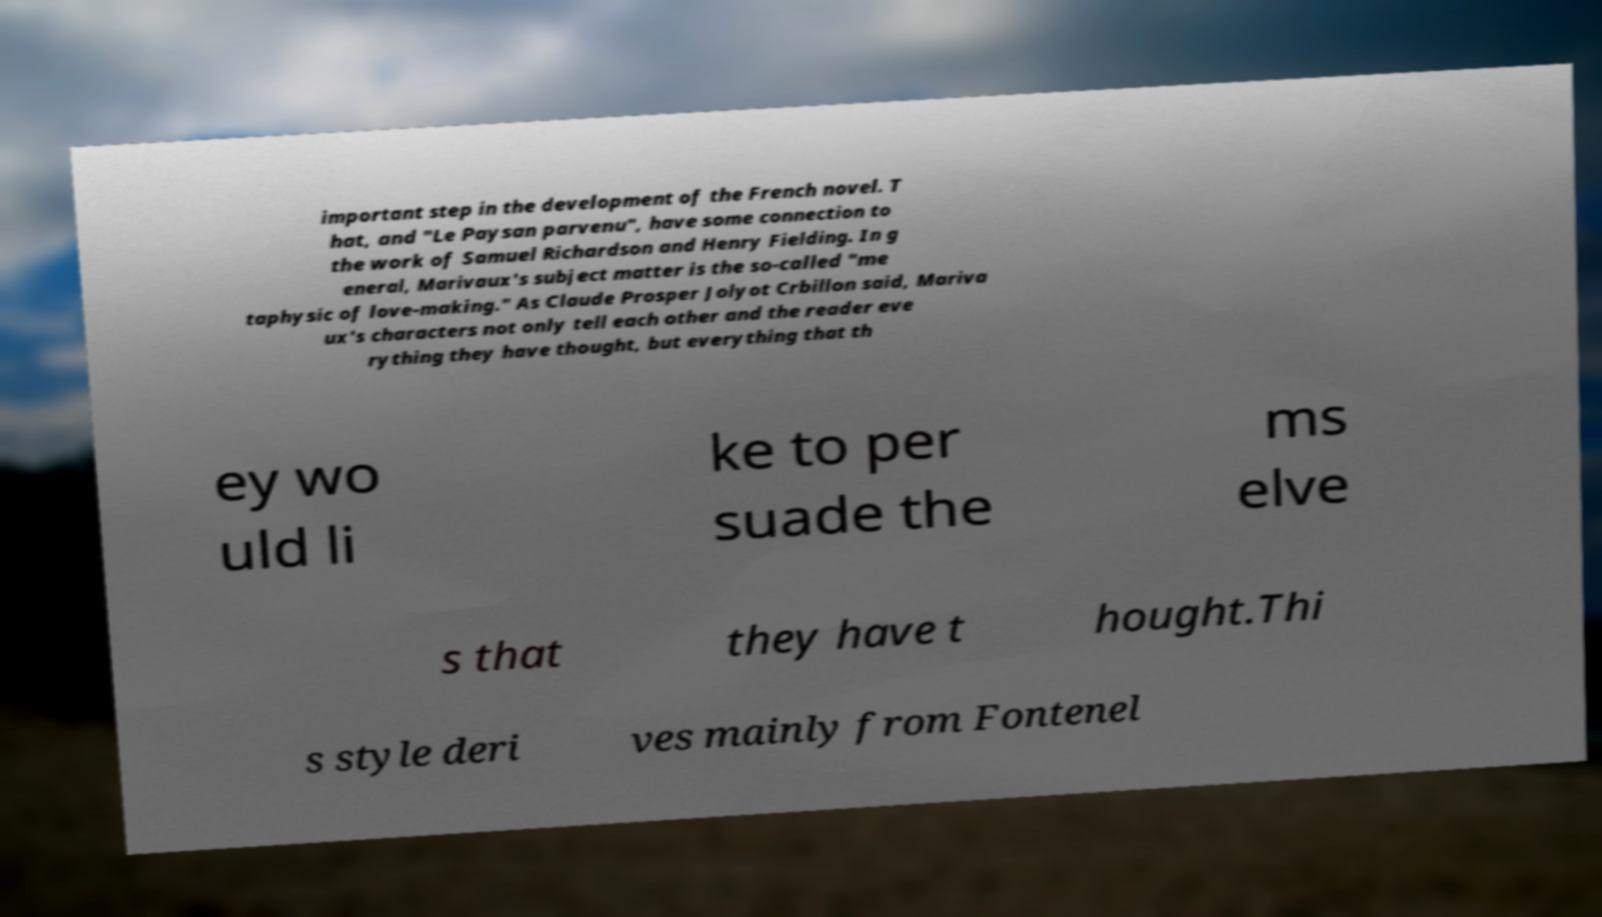Can you read and provide the text displayed in the image?This photo seems to have some interesting text. Can you extract and type it out for me? important step in the development of the French novel. T hat, and "Le Paysan parvenu", have some connection to the work of Samuel Richardson and Henry Fielding. In g eneral, Marivaux's subject matter is the so-called "me taphysic of love-making." As Claude Prosper Jolyot Crbillon said, Mariva ux's characters not only tell each other and the reader eve rything they have thought, but everything that th ey wo uld li ke to per suade the ms elve s that they have t hought.Thi s style deri ves mainly from Fontenel 